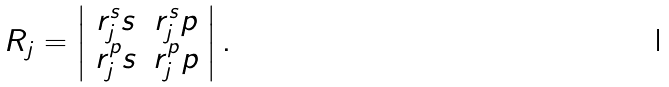<formula> <loc_0><loc_0><loc_500><loc_500>R _ { j } = \left | \begin{array} { c c } r _ { j } ^ { s } s & r _ { j } ^ { s } p \\ r _ { j } ^ { p } s & r _ { j } ^ { p } p \end{array} \right | .</formula> 